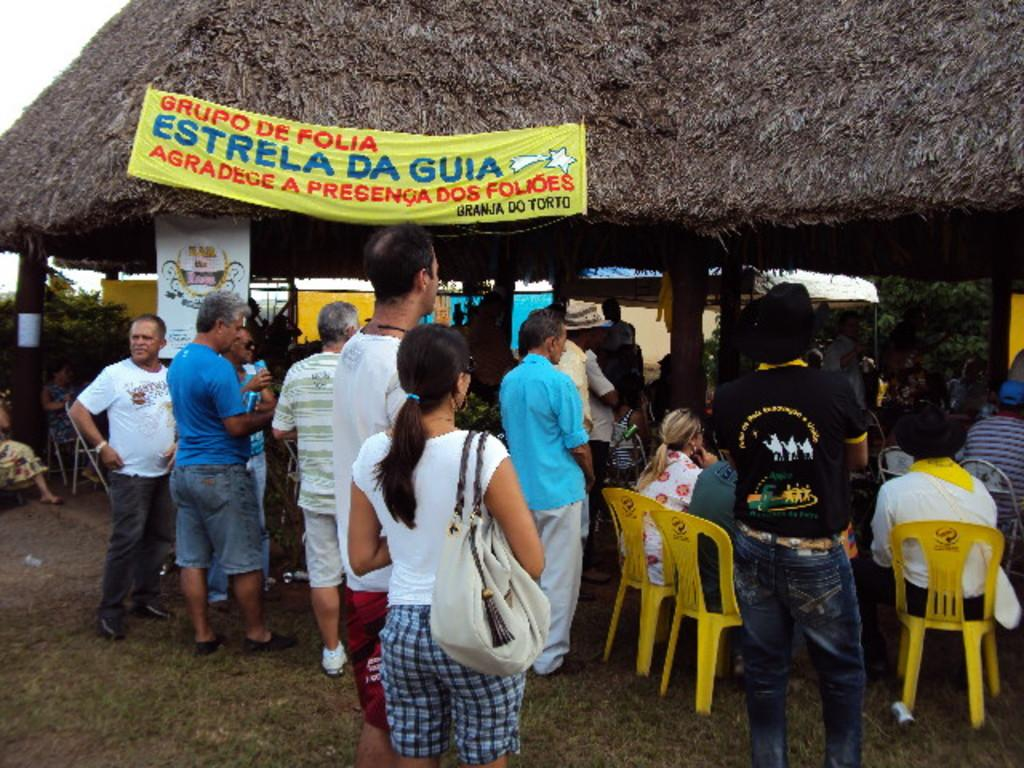How many people are in the image? There is a group of people in the image, but the exact number cannot be determined from the provided facts. What are some of the people in the image doing? Some people are sitting on chairs in the image. What type of vegetation can be seen in the image? There are trees in the image. What is hanging in the image? There is a banner in the image. What is the purpose of the board in the image? The purpose of the board in the image cannot be determined from the provided facts. What type of structure is present in the image? There is a hut in the image. What is visible in the background of the image? The sky is visible in the background of the image. What type of sign can be seen on the hut in the image? There is no sign present on the hut in the image. How does the fire affect the people in the image? There is no fire present in the image. What is the group of people wishing for in the image? There is no indication of any wishes in the image. 